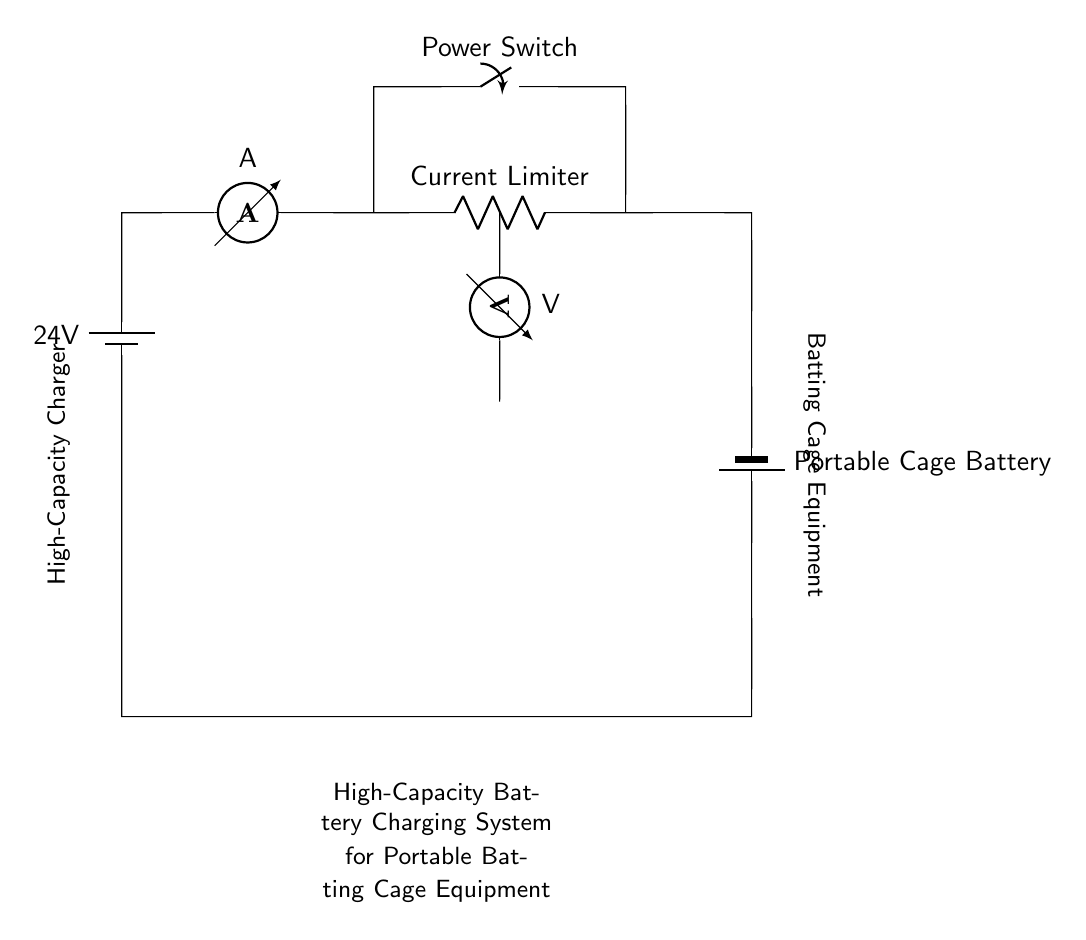What is the voltage of the battery? The circuit contains a battery labeled with a voltage of 24V at the top left corner. This indicates the potential difference provided by the battery.
Answer: 24V What component limits current in this circuit? The circuit diagram includes a component labeled as "Current Limiter" which is used to regulate the flow of current. It is positioned between the ammeter and the battery connections.
Answer: Current Limiter How many batteries are shown in the diagram? There are two batteries depicted in the circuit: one on the top labeled as a 24V battery and another at the bottom labeled as a portable cage battery.
Answer: Two What type of switch is included in the circuit? The diagram shows a component labeled as "Power Switch", indicating that it is used to control the power flow in the circuit. It is located above the ammeter.
Answer: Power Switch What does the voltmeter measure in this circuit? The voltmeter, located on the right side of the ammeter, is labeled with "V" and measures the voltage across specific points in the circuit, helping to monitor the electrical potential difference.
Answer: Voltage Can you identify the purpose of this circuit? The circuit is designed for a high-capacity battery charging system specifically for portable batting cage equipment, as indicated by the description at the bottom. This suggests its application in sports equipment charging.
Answer: Charging System 